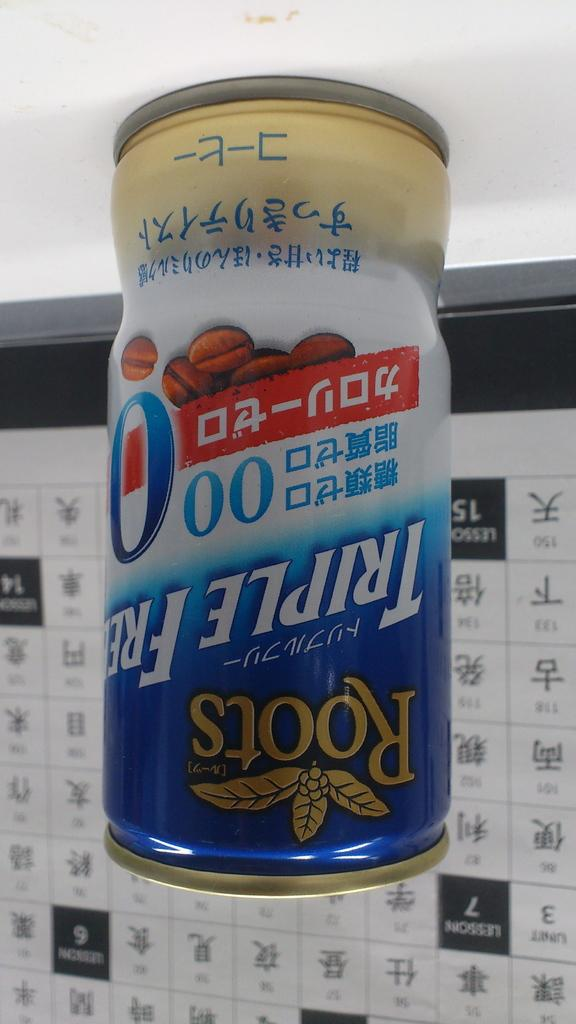<image>
Render a clear and concise summary of the photo. A can of a beverage called Roots sits on a table in front of a background with Asian language writing. 